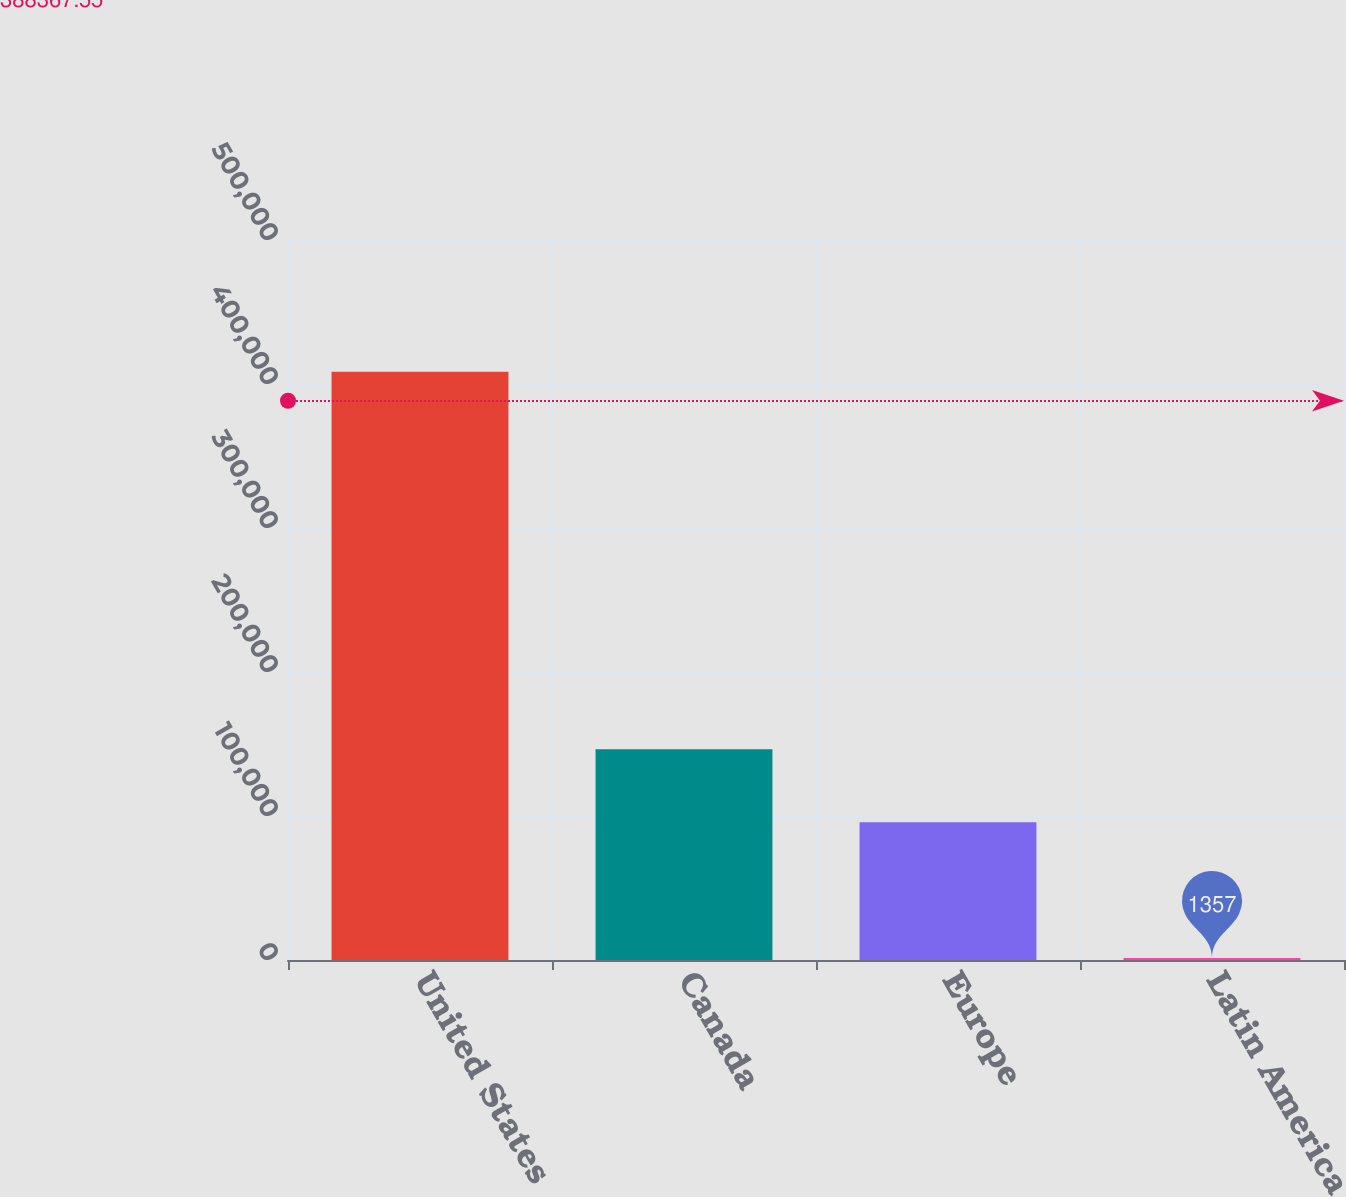<chart> <loc_0><loc_0><loc_500><loc_500><bar_chart><fcel>United States<fcel>Canada<fcel>Europe<fcel>Latin America<nl><fcel>408573<fcel>146391<fcel>95602<fcel>1357<nl></chart> 